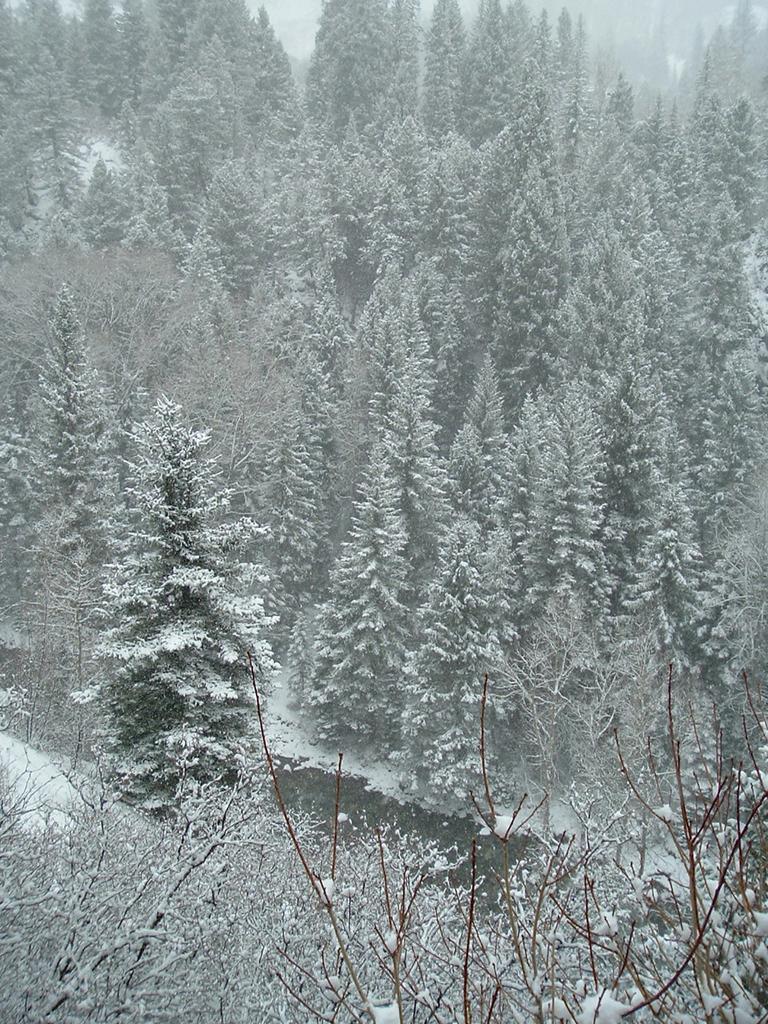Can you describe this image briefly? In this image there are trees fully covered with snow. 